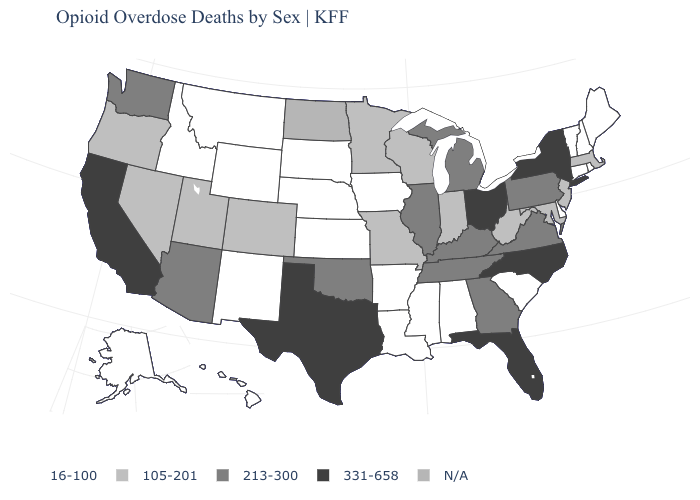Name the states that have a value in the range 105-201?
Answer briefly. Colorado, Indiana, Maryland, Massachusetts, Minnesota, Missouri, Nevada, New Jersey, Oregon, Utah, West Virginia, Wisconsin. What is the value of Michigan?
Write a very short answer. 213-300. What is the value of Rhode Island?
Concise answer only. 16-100. What is the value of Wyoming?
Give a very brief answer. 16-100. Name the states that have a value in the range 105-201?
Answer briefly. Colorado, Indiana, Maryland, Massachusetts, Minnesota, Missouri, Nevada, New Jersey, Oregon, Utah, West Virginia, Wisconsin. Which states have the lowest value in the USA?
Quick response, please. Alabama, Alaska, Arkansas, Connecticut, Delaware, Hawaii, Idaho, Iowa, Kansas, Louisiana, Maine, Mississippi, Montana, Nebraska, New Hampshire, New Mexico, Rhode Island, South Carolina, South Dakota, Vermont, Wyoming. What is the lowest value in the MidWest?
Be succinct. 16-100. Does the first symbol in the legend represent the smallest category?
Concise answer only. Yes. What is the value of Indiana?
Give a very brief answer. 105-201. Does New York have the highest value in the Northeast?
Quick response, please. Yes. Name the states that have a value in the range 105-201?
Concise answer only. Colorado, Indiana, Maryland, Massachusetts, Minnesota, Missouri, Nevada, New Jersey, Oregon, Utah, West Virginia, Wisconsin. What is the value of South Carolina?
Keep it brief. 16-100. What is the value of Delaware?
Quick response, please. 16-100. What is the value of Wyoming?
Be succinct. 16-100. What is the value of Colorado?
Quick response, please. 105-201. 